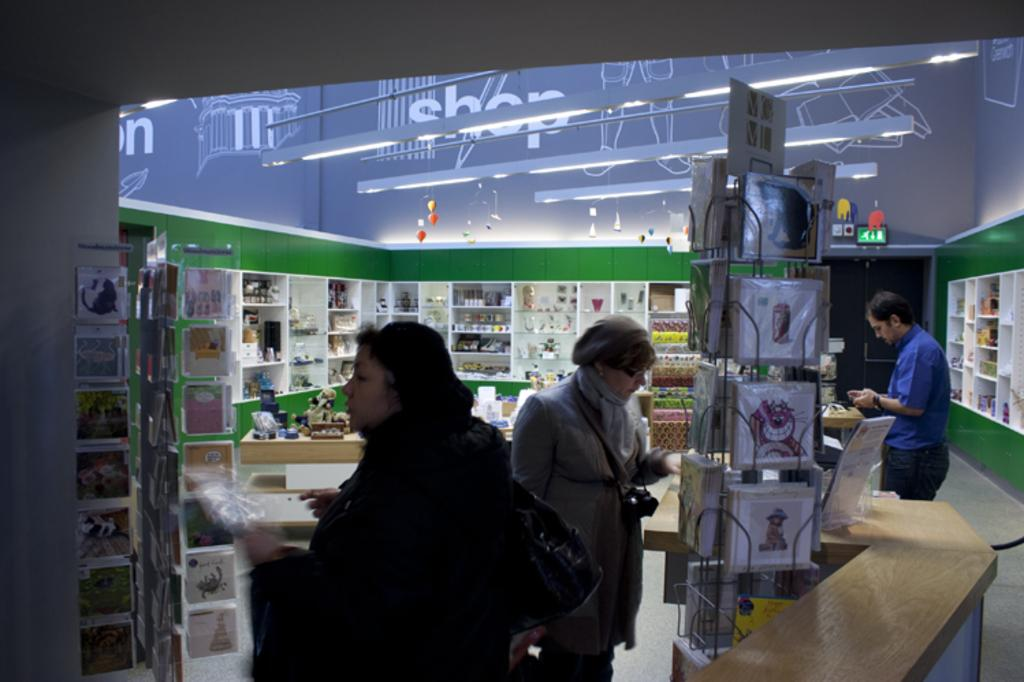<image>
Present a compact description of the photo's key features. People shopping in a store with the word SHOP on the ceiling. 